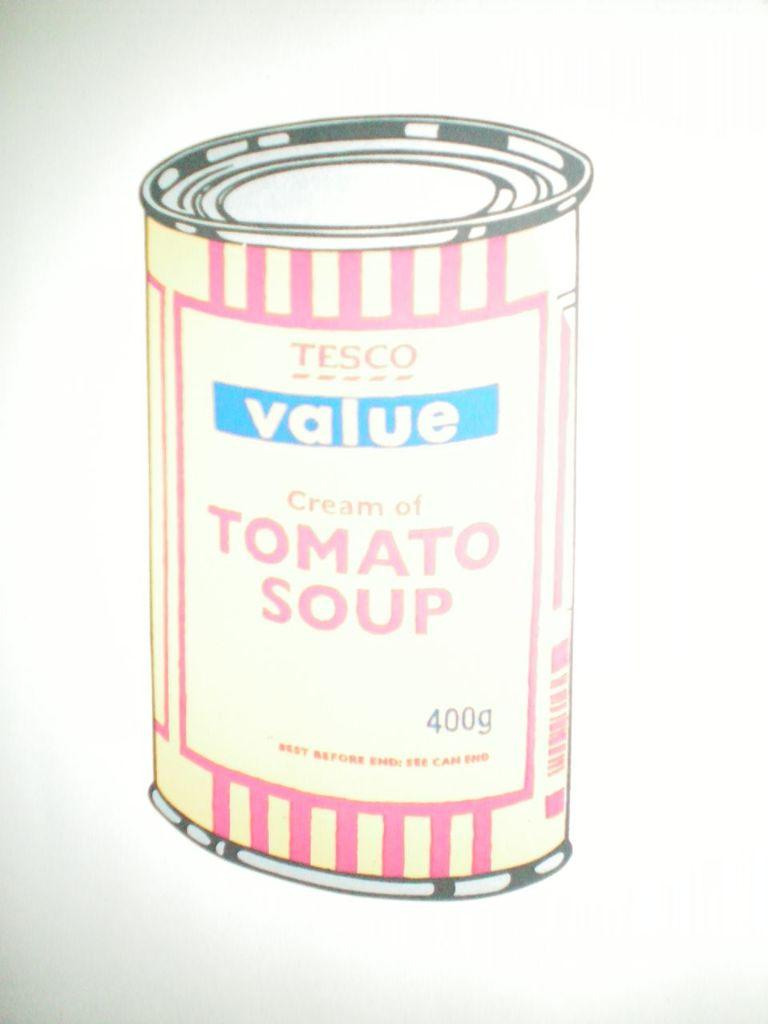<image>
Give a short and clear explanation of the subsequent image. A Tesco value brand can of Tomato Soup. 